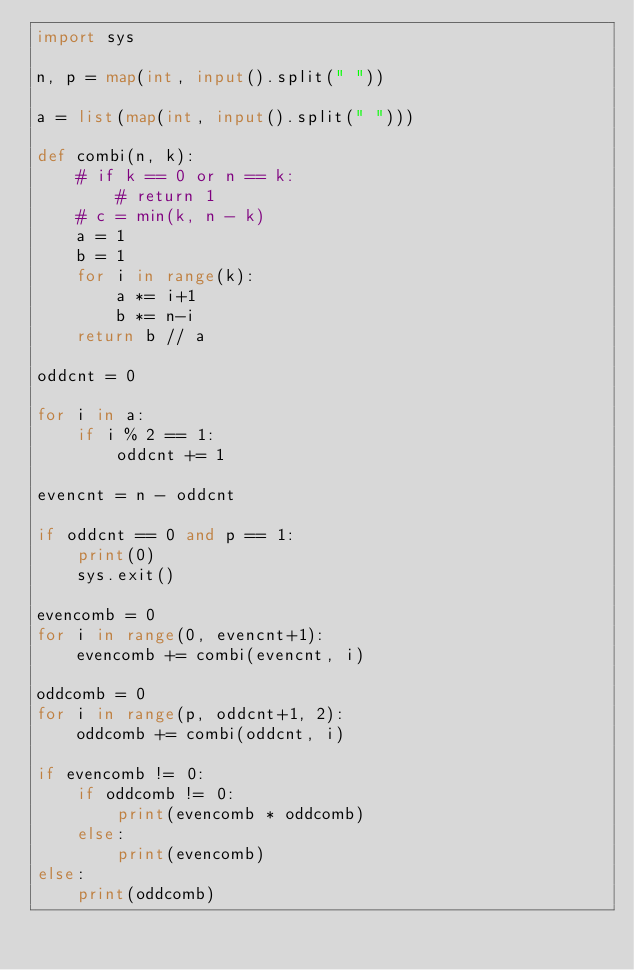Convert code to text. <code><loc_0><loc_0><loc_500><loc_500><_Python_>import sys

n, p = map(int, input().split(" "))

a = list(map(int, input().split(" ")))

def combi(n, k):
    # if k == 0 or n == k:
        # return 1
    # c = min(k, n - k)
    a = 1
    b = 1
    for i in range(k):
        a *= i+1
        b *= n-i
    return b // a

oddcnt = 0

for i in a:
    if i % 2 == 1:
        oddcnt += 1

evencnt = n - oddcnt

if oddcnt == 0 and p == 1:
    print(0)
    sys.exit()

evencomb = 0
for i in range(0, evencnt+1):
    evencomb += combi(evencnt, i)

oddcomb = 0
for i in range(p, oddcnt+1, 2):
    oddcomb += combi(oddcnt, i)

if evencomb != 0:
    if oddcomb != 0:
        print(evencomb * oddcomb)
    else:
        print(evencomb)
else:
    print(oddcomb)
</code> 